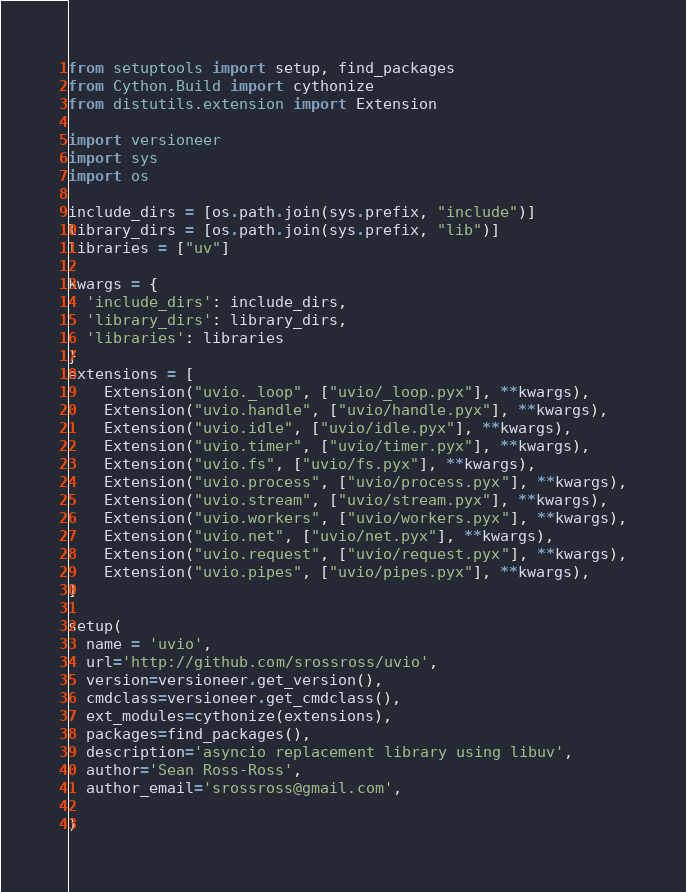<code> <loc_0><loc_0><loc_500><loc_500><_Python_>from setuptools import setup, find_packages
from Cython.Build import cythonize
from distutils.extension import Extension

import versioneer
import sys
import os

include_dirs = [os.path.join(sys.prefix, "include")]
library_dirs = [os.path.join(sys.prefix, "lib")]
libraries = ["uv"]

kwargs = {
  'include_dirs': include_dirs,
  'library_dirs': library_dirs,
  'libraries': libraries
}
extensions = [
    Extension("uvio._loop", ["uvio/_loop.pyx"], **kwargs),
    Extension("uvio.handle", ["uvio/handle.pyx"], **kwargs),
    Extension("uvio.idle", ["uvio/idle.pyx"], **kwargs),
    Extension("uvio.timer", ["uvio/timer.pyx"], **kwargs),
    Extension("uvio.fs", ["uvio/fs.pyx"], **kwargs),
    Extension("uvio.process", ["uvio/process.pyx"], **kwargs),
    Extension("uvio.stream", ["uvio/stream.pyx"], **kwargs),
    Extension("uvio.workers", ["uvio/workers.pyx"], **kwargs),
    Extension("uvio.net", ["uvio/net.pyx"], **kwargs),
    Extension("uvio.request", ["uvio/request.pyx"], **kwargs),
    Extension("uvio.pipes", ["uvio/pipes.pyx"], **kwargs),
]

setup(
  name = 'uvio',
  url='http://github.com/srossross/uvio',
  version=versioneer.get_version(),
  cmdclass=versioneer.get_cmdclass(),
  ext_modules=cythonize(extensions),
  packages=find_packages(),
  description='asyncio replacement library using libuv',
  author='Sean Ross-Ross',
  author_email='srossross@gmail.com',

)
</code> 